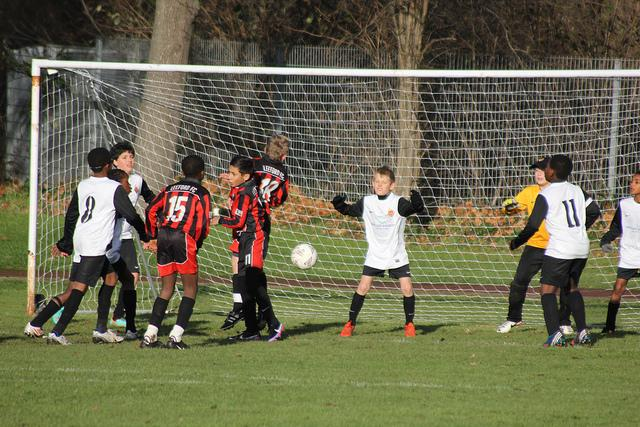Why is one kid wearing yellow? Please explain your reasoning. goalie. The kid in yellow is a soccer player, not a referee, umpire, or water boy. he is wearing a different color to distinguish himself from the other players. 